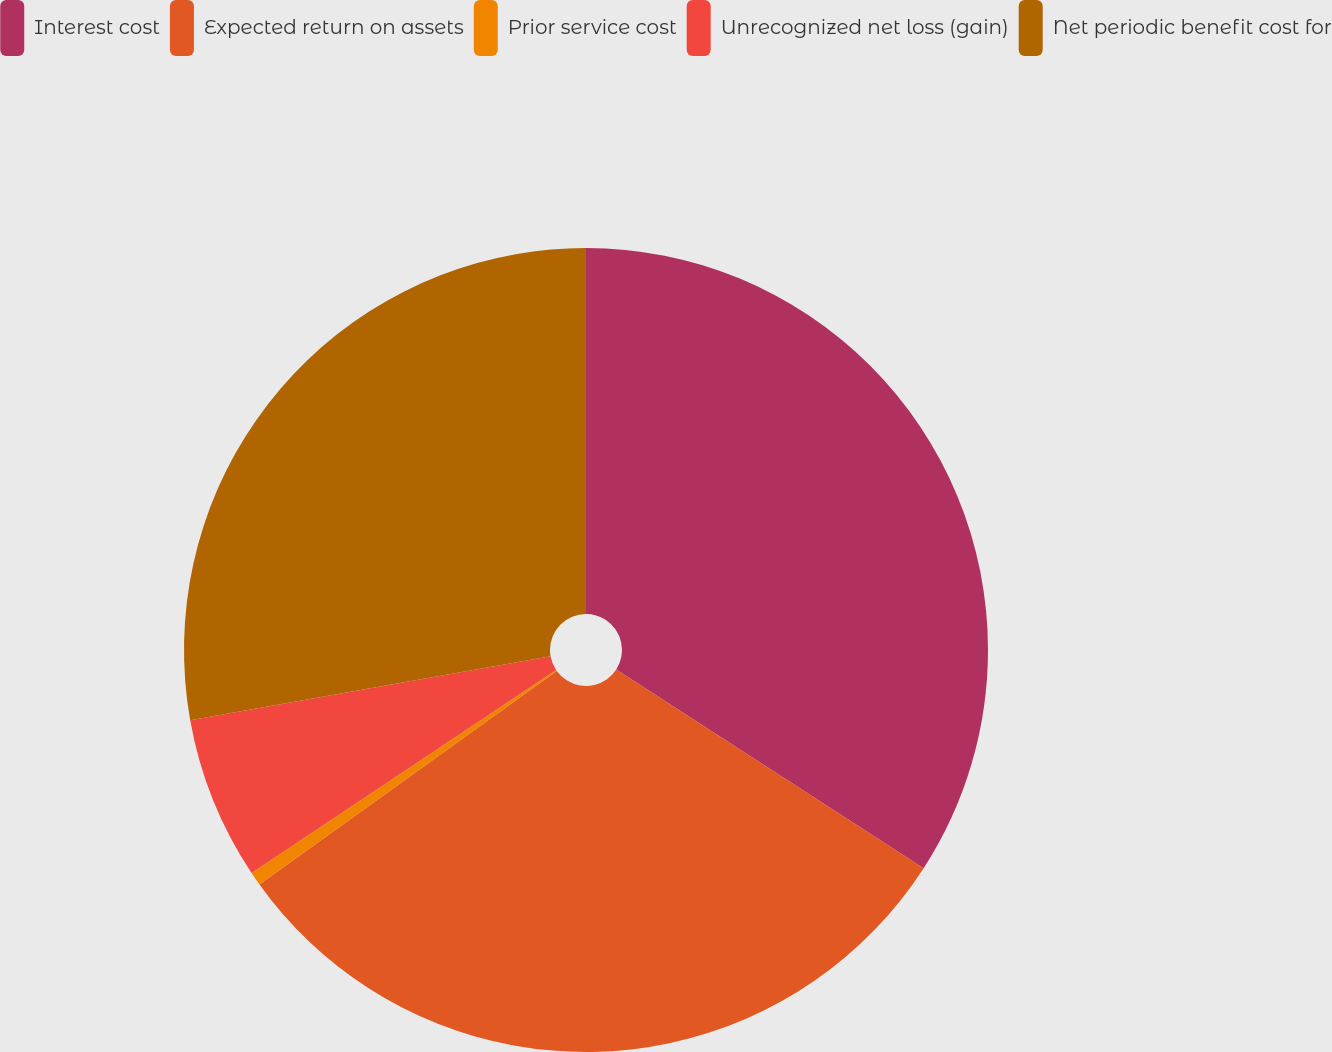<chart> <loc_0><loc_0><loc_500><loc_500><pie_chart><fcel>Interest cost<fcel>Expected return on assets<fcel>Prior service cost<fcel>Unrecognized net loss (gain)<fcel>Net periodic benefit cost for<nl><fcel>34.13%<fcel>30.96%<fcel>0.55%<fcel>6.56%<fcel>27.8%<nl></chart> 